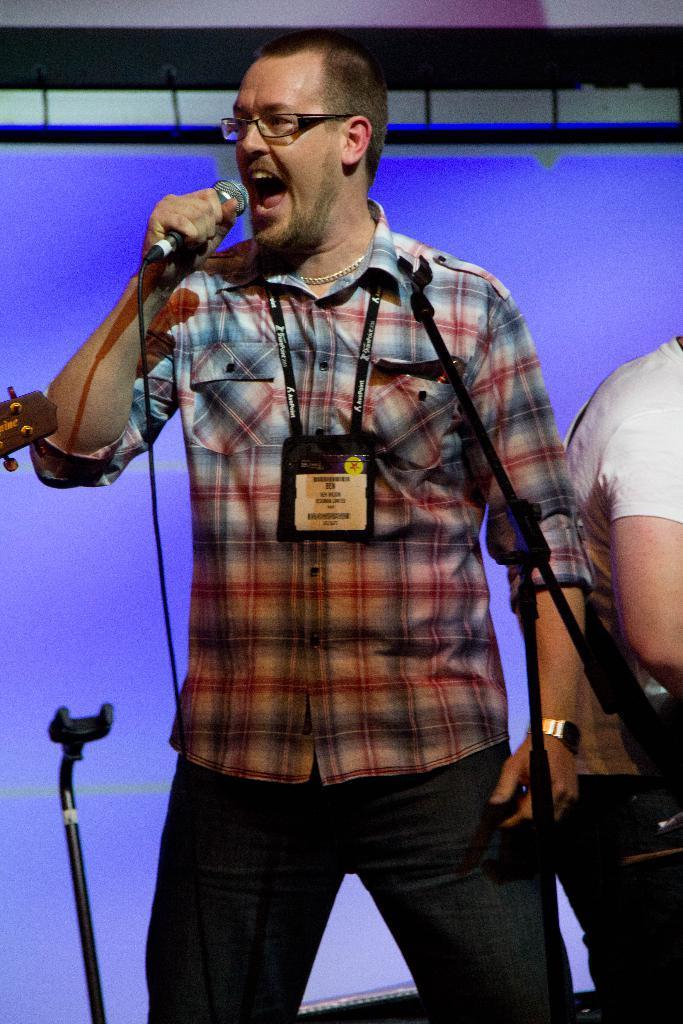Could you give a brief overview of what you see in this image? There is a man standing and singing a song. He is holding a mike. At the right corner of the image I can see another person standing. This looks like a mike stand. And the man in the middle is wearing a badge. 